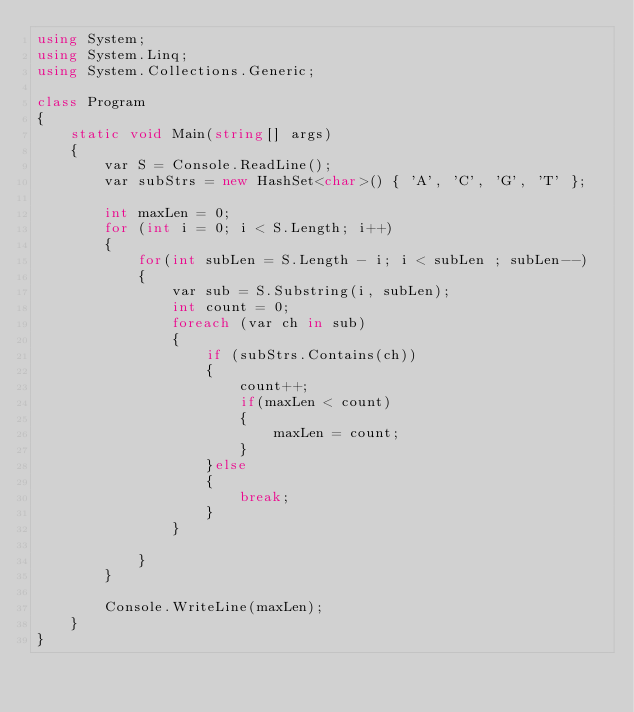Convert code to text. <code><loc_0><loc_0><loc_500><loc_500><_C#_>using System;
using System.Linq;
using System.Collections.Generic;

class Program
{
    static void Main(string[] args)
    {
        var S = Console.ReadLine();
        var subStrs = new HashSet<char>() { 'A', 'C', 'G', 'T' };

        int maxLen = 0;
        for (int i = 0; i < S.Length; i++)
        {
            for(int subLen = S.Length - i; i < subLen ; subLen--)
            {
                var sub = S.Substring(i, subLen);
                int count = 0;
                foreach (var ch in sub)
                {
                    if (subStrs.Contains(ch))
                    {
                        count++;
                        if(maxLen < count)
                        {
                            maxLen = count;
                        }
                    }else
                    {
                        break;
                    }
                }

            }
        }

        Console.WriteLine(maxLen);
    }
}

</code> 